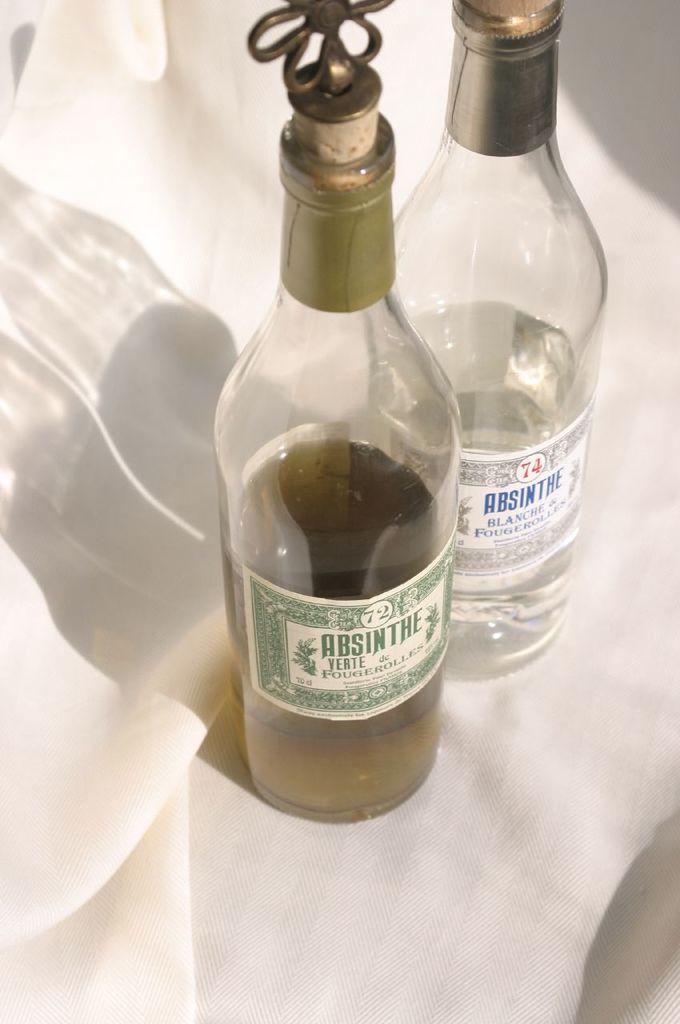What objects are made of glass in the image? There are two glass bottles in the image. What type of material is the cloth in the image made of? The cloth in the image is made of white material. What type of needle can be seen sewing the wood in the image? There is no needle or wood present in the image. How many flies can be seen buzzing around the glass bottles in the image? There are no flies present in the image. 